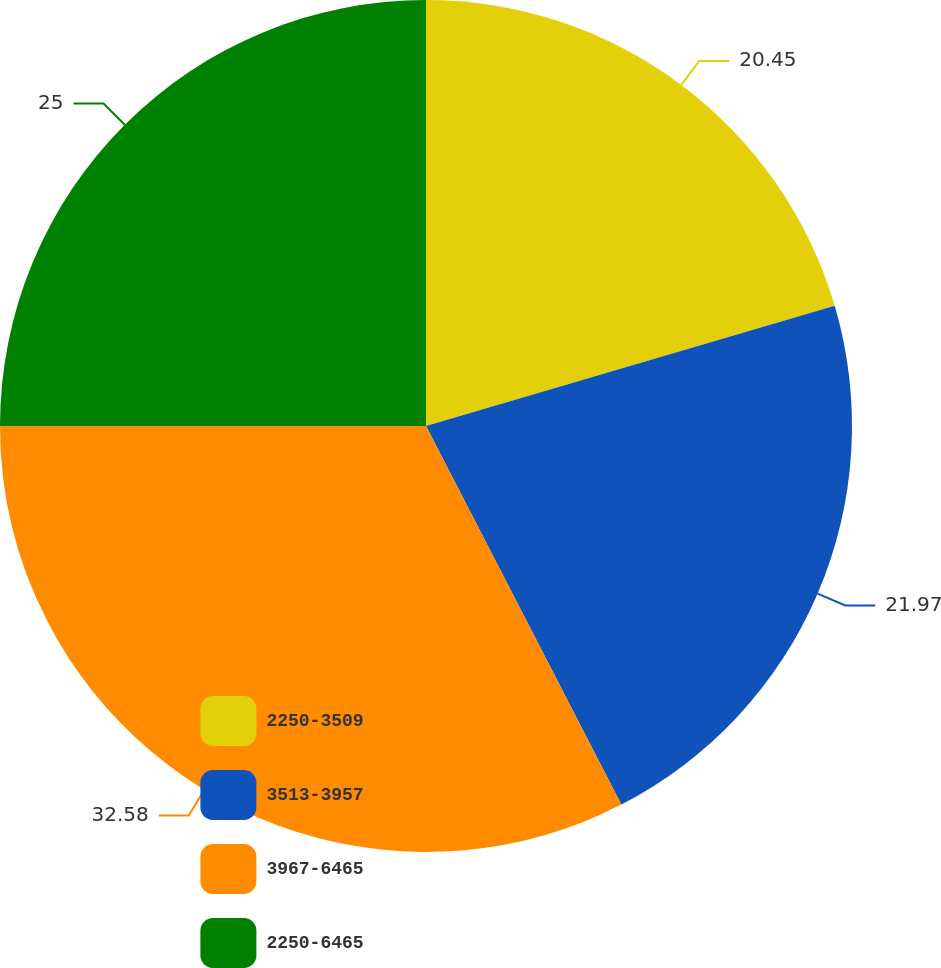<chart> <loc_0><loc_0><loc_500><loc_500><pie_chart><fcel>2250-3509<fcel>3513-3957<fcel>3967-6465<fcel>2250-6465<nl><fcel>20.45%<fcel>21.97%<fcel>32.58%<fcel>25.0%<nl></chart> 